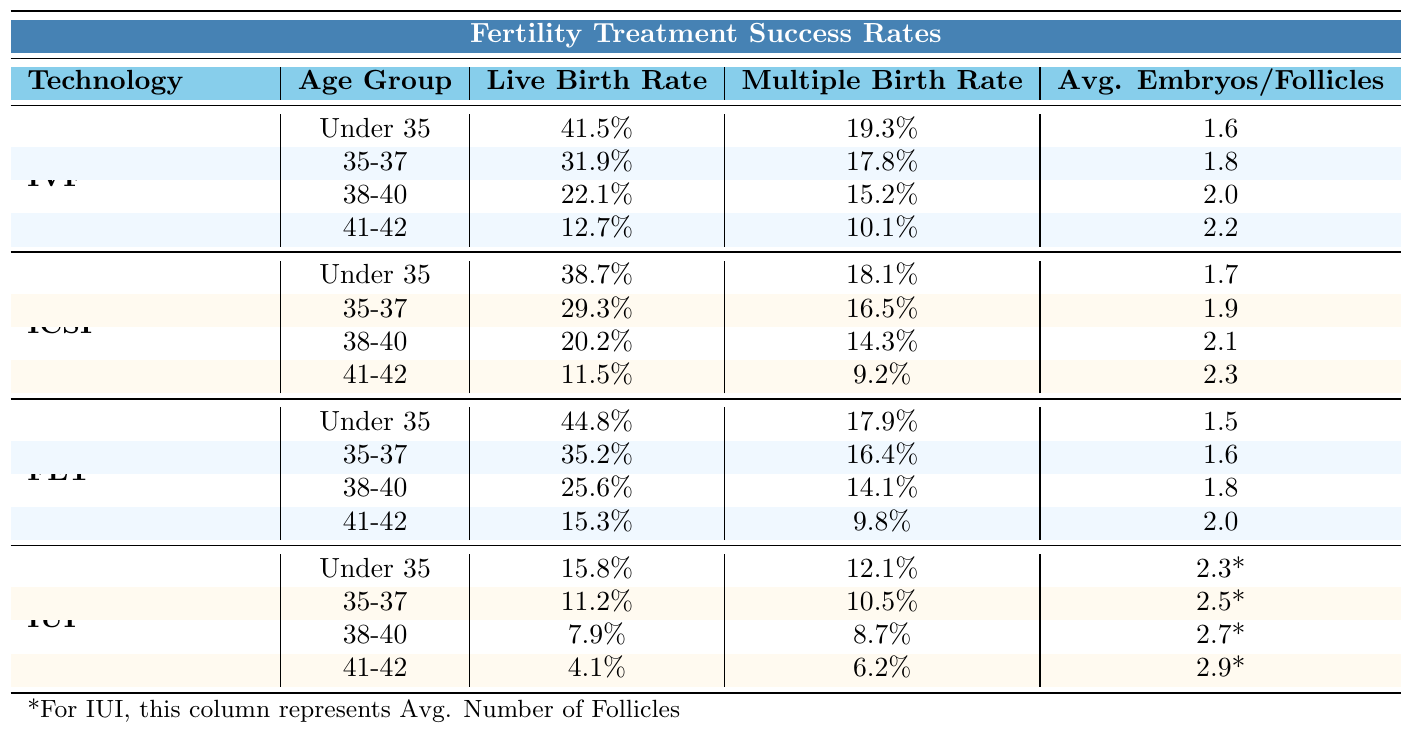What is the live birth rate for women aged 35-37 undergoing IVF? The live birth rate for the 35-37 age group in IVF is listed in the table as 31.9%.
Answer: 31.9% Which assisted reproductive technology has the highest live birth rate for women under 35? The table indicates that Frozen Embryo Transfer (FET) has the highest live birth rate for the under 35 age group at 44.8%.
Answer: FET What is the average number of embryos transferred in ICSI for women aged 41-42? The table shows that for the 41-42 age group in ICSI, the average number of embryos transferred is 2.3.
Answer: 2.3 Is the multiple birth rate higher in IUI compared to IVF for women aged 38-40? The table shows a multiple birth rate of 15.2% for IVF and 8.7% for IUI in the 38-40 age group; therefore, IVF has a higher rate.
Answer: No What is the difference in live birth rates between IVF and ICSI for women aged 38-40? According to the table, the live birth rate for IVF in this group is 22.1%, while for ICSI, it is 20.2%. The difference is 22.1% - 20.2% = 1.9%.
Answer: 1.9% Which technology shows the lowest live birth rate in women aged 41-42? The table indicates that IUI has the lowest live birth rate for the 41-42 age group at 4.1% compared to IVF (12.7%), ICSI (11.5%), and FET (15.3%).
Answer: IUI If a woman aged 35-37 chooses FET, what is her chance of having a live birth? The live birth rate for women aged 35-37 undergoing FET is provided in the table as 35.2%.
Answer: 35.2% What is the trend in live birth rates from the under 35 group to the 41-42 group across all technologies? Examining the table, it is apparent that live birth rates decrease as age increases across all technologies for the specified age groups.
Answer: Rates decrease How much higher is the average number of embryos transferred in IVF compared to IUI for women aged 41-42? The table shows that the average number of embryos in IVF is 2.2 and in IUI, it is indicated as 2.9, representing a scenario where IUI actually shows more follicles rather than embryos. Thus, IVFs 2.2 - 2.0 from FET = 0.2 less embryos transferred referring specifically to egg retrieval techniques rather than potential pregnancies.
Answer: 0.2 fewer What technology allows the least number of embryos to be transferred on average for women under 35? The table shows that Frozen Embryo Transfer (FET) has the lowest average number of embryos transferred at 1.5 for women under 35 compared to 1.6 in IVF.
Answer: FET Which age group has the highest multiple birth rate in IVF? The table specifies that the age group under 35 has the highest multiple birth rate of 19.3% in IVF.
Answer: Under 35 